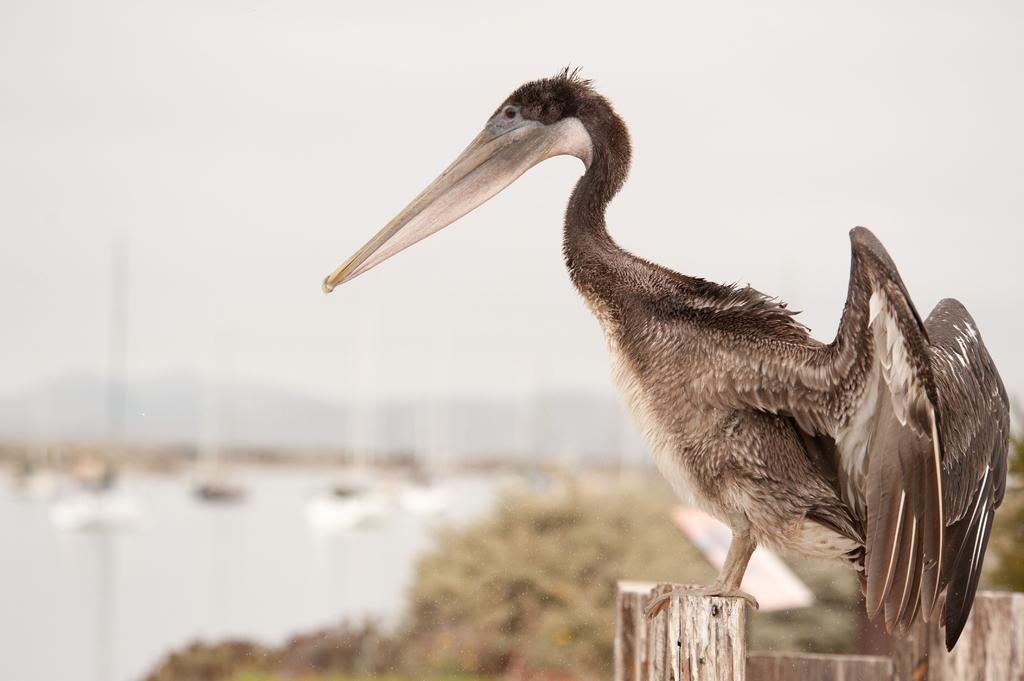Please provide a concise description of this image. In this image we can see a bird on a wooden surface. Behind the bird we can see a group of trees and water. The background of the image is blurred. 